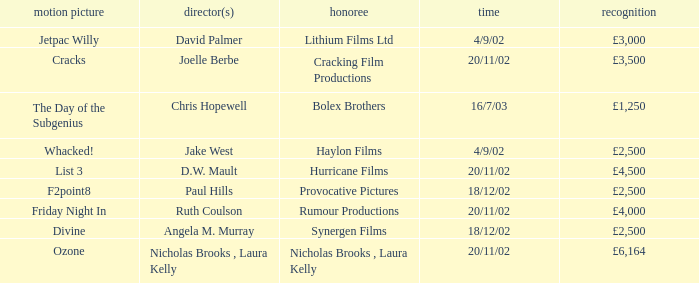Who won an award of £3,000 on 4/9/02? Lithium Films Ltd. Could you parse the entire table? {'header': ['motion picture', 'director(s)', 'honoree', 'time', 'recognition'], 'rows': [['Jetpac Willy', 'David Palmer', 'Lithium Films Ltd', '4/9/02', '£3,000'], ['Cracks', 'Joelle Berbe', 'Cracking Film Productions', '20/11/02', '£3,500'], ['The Day of the Subgenius', 'Chris Hopewell', 'Bolex Brothers', '16/7/03', '£1,250'], ['Whacked!', 'Jake West', 'Haylon Films', '4/9/02', '£2,500'], ['List 3', 'D.W. Mault', 'Hurricane Films', '20/11/02', '£4,500'], ['F2point8', 'Paul Hills', 'Provocative Pictures', '18/12/02', '£2,500'], ['Friday Night In', 'Ruth Coulson', 'Rumour Productions', '20/11/02', '£4,000'], ['Divine', 'Angela M. Murray', 'Synergen Films', '18/12/02', '£2,500'], ['Ozone', 'Nicholas Brooks , Laura Kelly', 'Nicholas Brooks , Laura Kelly', '20/11/02', '£6,164']]} 